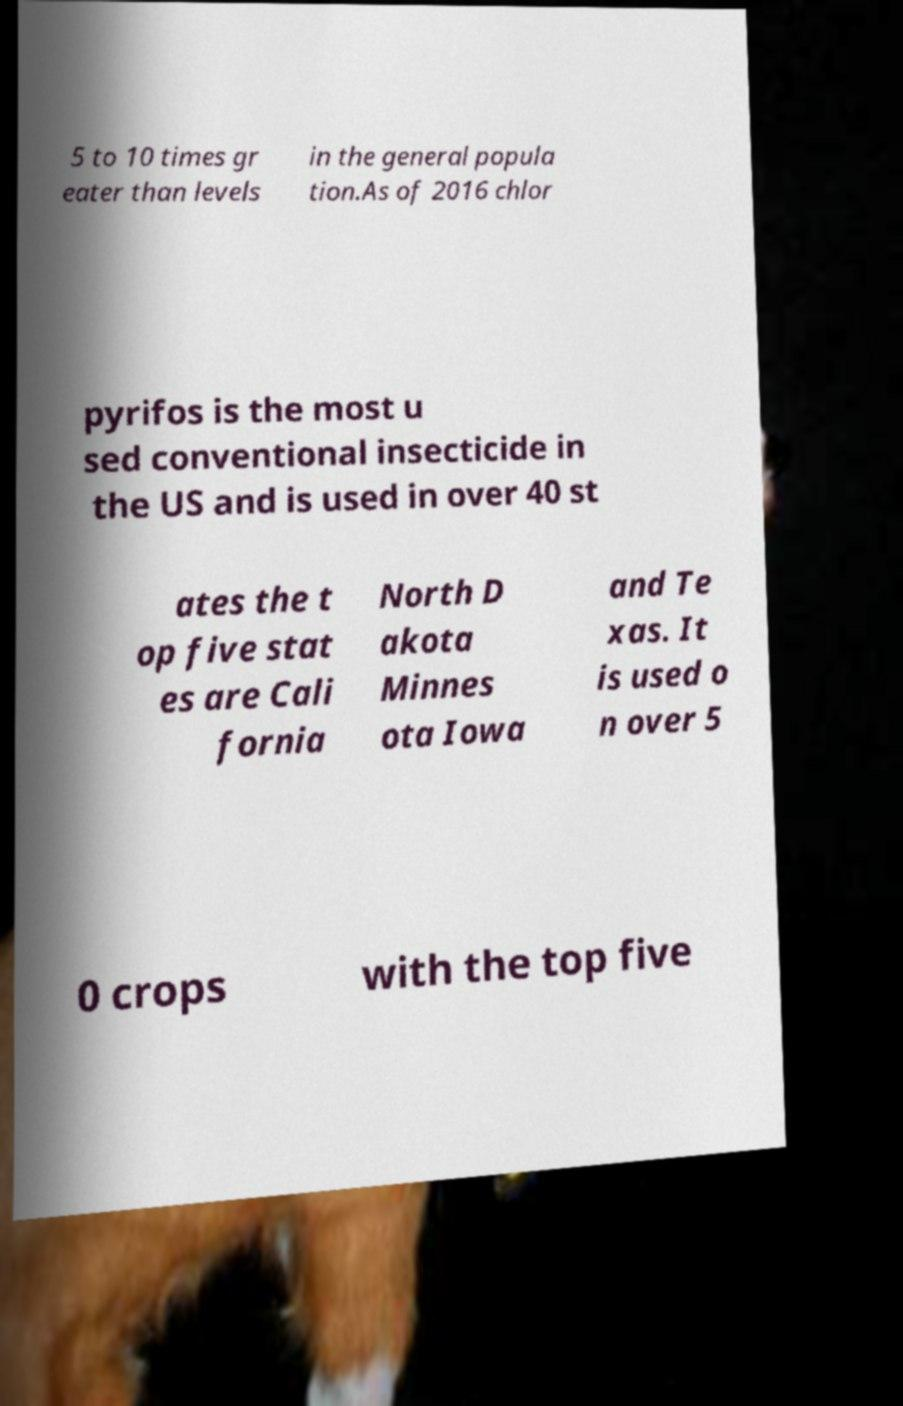Please identify and transcribe the text found in this image. 5 to 10 times gr eater than levels in the general popula tion.As of 2016 chlor pyrifos is the most u sed conventional insecticide in the US and is used in over 40 st ates the t op five stat es are Cali fornia North D akota Minnes ota Iowa and Te xas. It is used o n over 5 0 crops with the top five 